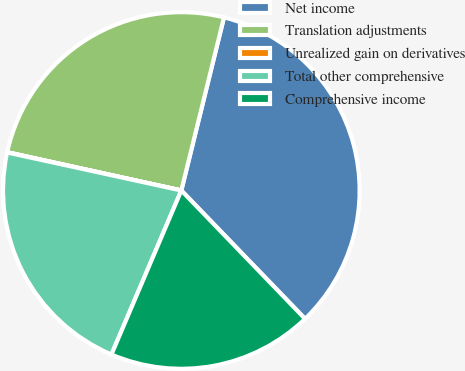Convert chart to OTSL. <chart><loc_0><loc_0><loc_500><loc_500><pie_chart><fcel>Net income<fcel>Translation adjustments<fcel>Unrealized gain on derivatives<fcel>Total other comprehensive<fcel>Comprehensive income<nl><fcel>33.95%<fcel>25.4%<fcel>0.03%<fcel>22.01%<fcel>18.62%<nl></chart> 